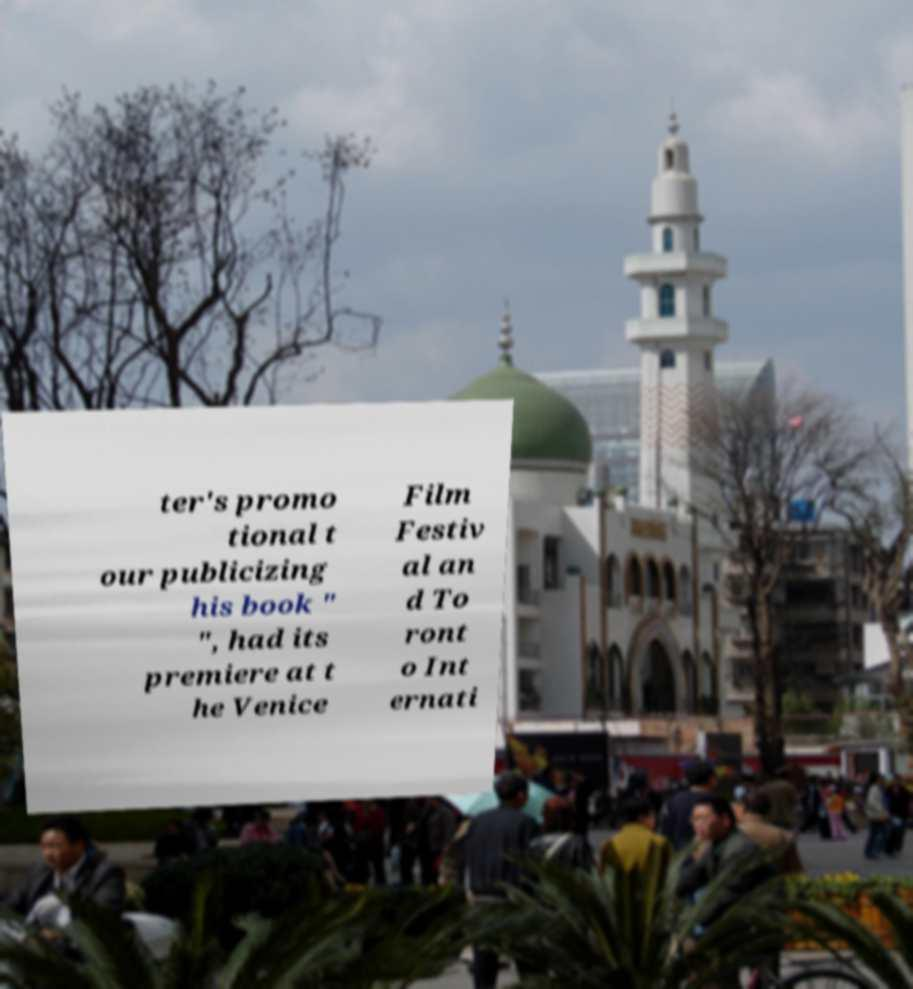What messages or text are displayed in this image? I need them in a readable, typed format. ter's promo tional t our publicizing his book " ", had its premiere at t he Venice Film Festiv al an d To ront o Int ernati 